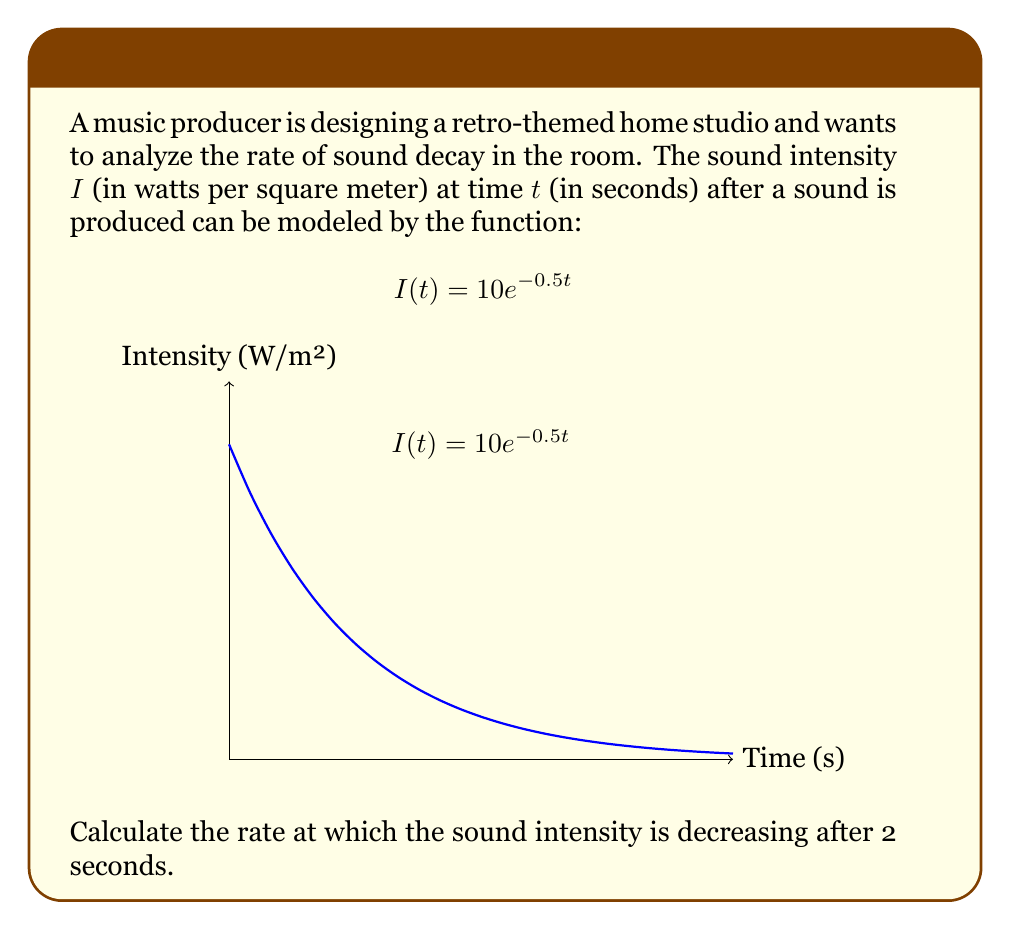Teach me how to tackle this problem. To find the rate at which the sound intensity is decreasing at $t=2$ seconds, we need to calculate the derivative of $I(t)$ and evaluate it at $t=2$. Then, we'll take the negative of this value since we're interested in the rate of decrease.

Step 1: Calculate the derivative of $I(t)$.
$$\frac{d}{dt}I(t) = \frac{d}{dt}(10e^{-0.5t})$$
Using the chain rule:
$$\frac{d}{dt}I(t) = 10 \cdot (-0.5) \cdot e^{-0.5t} = -5e^{-0.5t}$$

Step 2: Evaluate the derivative at $t=2$.
$$\frac{d}{dt}I(2) = -5e^{-0.5(2)} = -5e^{-1}$$

Step 3: Calculate the numerical value.
$$-5e^{-1} \approx -1.839$$

The negative sign indicates that the intensity is decreasing. The rate of decrease is the absolute value of this number.

Therefore, the sound intensity is decreasing at a rate of approximately 1.839 watts per square meter per second after 2 seconds.
Answer: 1.839 W/m²/s 